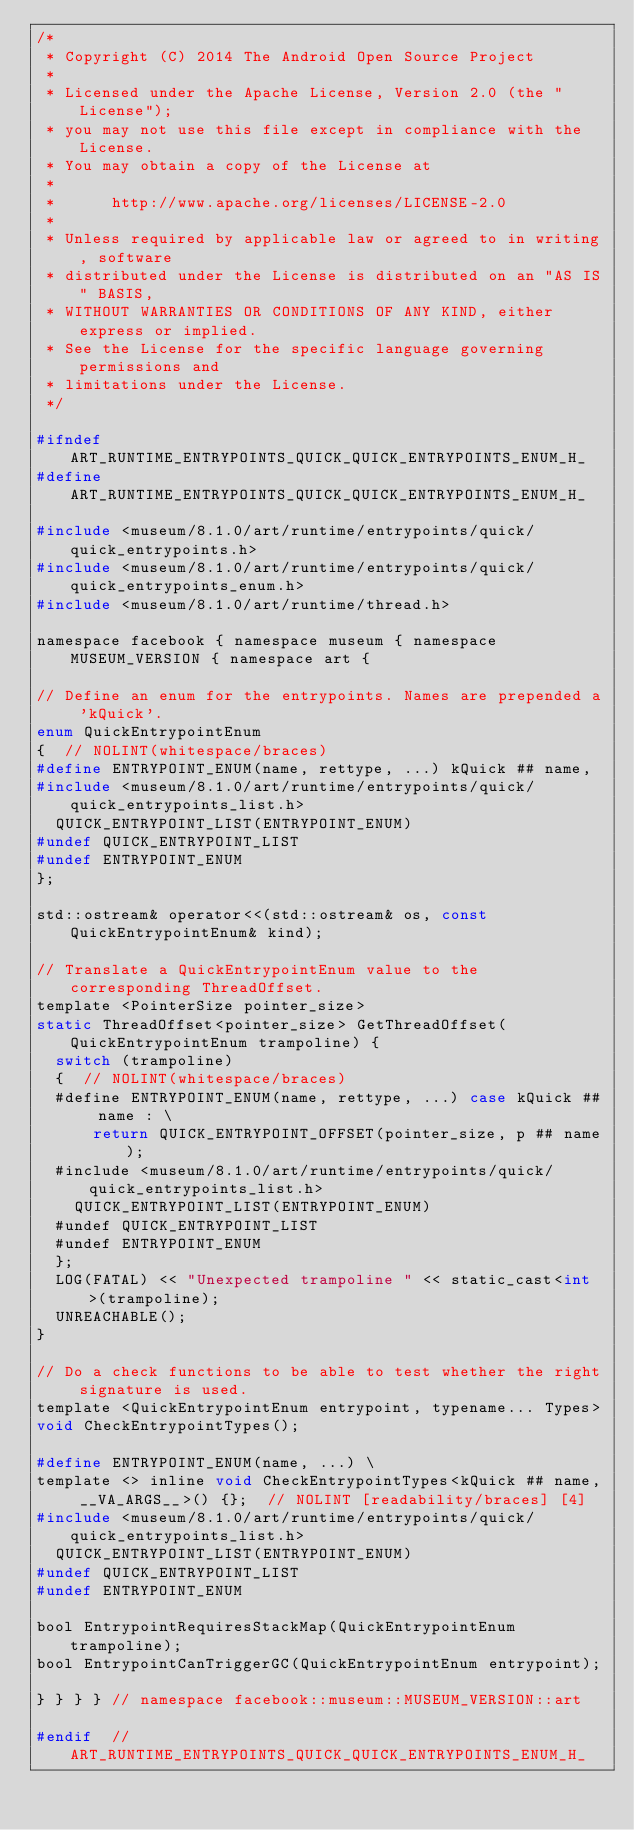Convert code to text. <code><loc_0><loc_0><loc_500><loc_500><_C_>/*
 * Copyright (C) 2014 The Android Open Source Project
 *
 * Licensed under the Apache License, Version 2.0 (the "License");
 * you may not use this file except in compliance with the License.
 * You may obtain a copy of the License at
 *
 *      http://www.apache.org/licenses/LICENSE-2.0
 *
 * Unless required by applicable law or agreed to in writing, software
 * distributed under the License is distributed on an "AS IS" BASIS,
 * WITHOUT WARRANTIES OR CONDITIONS OF ANY KIND, either express or implied.
 * See the License for the specific language governing permissions and
 * limitations under the License.
 */

#ifndef ART_RUNTIME_ENTRYPOINTS_QUICK_QUICK_ENTRYPOINTS_ENUM_H_
#define ART_RUNTIME_ENTRYPOINTS_QUICK_QUICK_ENTRYPOINTS_ENUM_H_

#include <museum/8.1.0/art/runtime/entrypoints/quick/quick_entrypoints.h>
#include <museum/8.1.0/art/runtime/entrypoints/quick/quick_entrypoints_enum.h>
#include <museum/8.1.0/art/runtime/thread.h>

namespace facebook { namespace museum { namespace MUSEUM_VERSION { namespace art {

// Define an enum for the entrypoints. Names are prepended a 'kQuick'.
enum QuickEntrypointEnum
{  // NOLINT(whitespace/braces)
#define ENTRYPOINT_ENUM(name, rettype, ...) kQuick ## name,
#include <museum/8.1.0/art/runtime/entrypoints/quick/quick_entrypoints_list.h>
  QUICK_ENTRYPOINT_LIST(ENTRYPOINT_ENUM)
#undef QUICK_ENTRYPOINT_LIST
#undef ENTRYPOINT_ENUM
};

std::ostream& operator<<(std::ostream& os, const QuickEntrypointEnum& kind);

// Translate a QuickEntrypointEnum value to the corresponding ThreadOffset.
template <PointerSize pointer_size>
static ThreadOffset<pointer_size> GetThreadOffset(QuickEntrypointEnum trampoline) {
  switch (trampoline)
  {  // NOLINT(whitespace/braces)
  #define ENTRYPOINT_ENUM(name, rettype, ...) case kQuick ## name : \
      return QUICK_ENTRYPOINT_OFFSET(pointer_size, p ## name);
  #include <museum/8.1.0/art/runtime/entrypoints/quick/quick_entrypoints_list.h>
    QUICK_ENTRYPOINT_LIST(ENTRYPOINT_ENUM)
  #undef QUICK_ENTRYPOINT_LIST
  #undef ENTRYPOINT_ENUM
  };
  LOG(FATAL) << "Unexpected trampoline " << static_cast<int>(trampoline);
  UNREACHABLE();
}

// Do a check functions to be able to test whether the right signature is used.
template <QuickEntrypointEnum entrypoint, typename... Types>
void CheckEntrypointTypes();

#define ENTRYPOINT_ENUM(name, ...) \
template <> inline void CheckEntrypointTypes<kQuick ## name, __VA_ARGS__>() {};  // NOLINT [readability/braces] [4]
#include <museum/8.1.0/art/runtime/entrypoints/quick/quick_entrypoints_list.h>
  QUICK_ENTRYPOINT_LIST(ENTRYPOINT_ENUM)
#undef QUICK_ENTRYPOINT_LIST
#undef ENTRYPOINT_ENUM

bool EntrypointRequiresStackMap(QuickEntrypointEnum trampoline);
bool EntrypointCanTriggerGC(QuickEntrypointEnum entrypoint);

} } } } // namespace facebook::museum::MUSEUM_VERSION::art

#endif  // ART_RUNTIME_ENTRYPOINTS_QUICK_QUICK_ENTRYPOINTS_ENUM_H_
</code> 